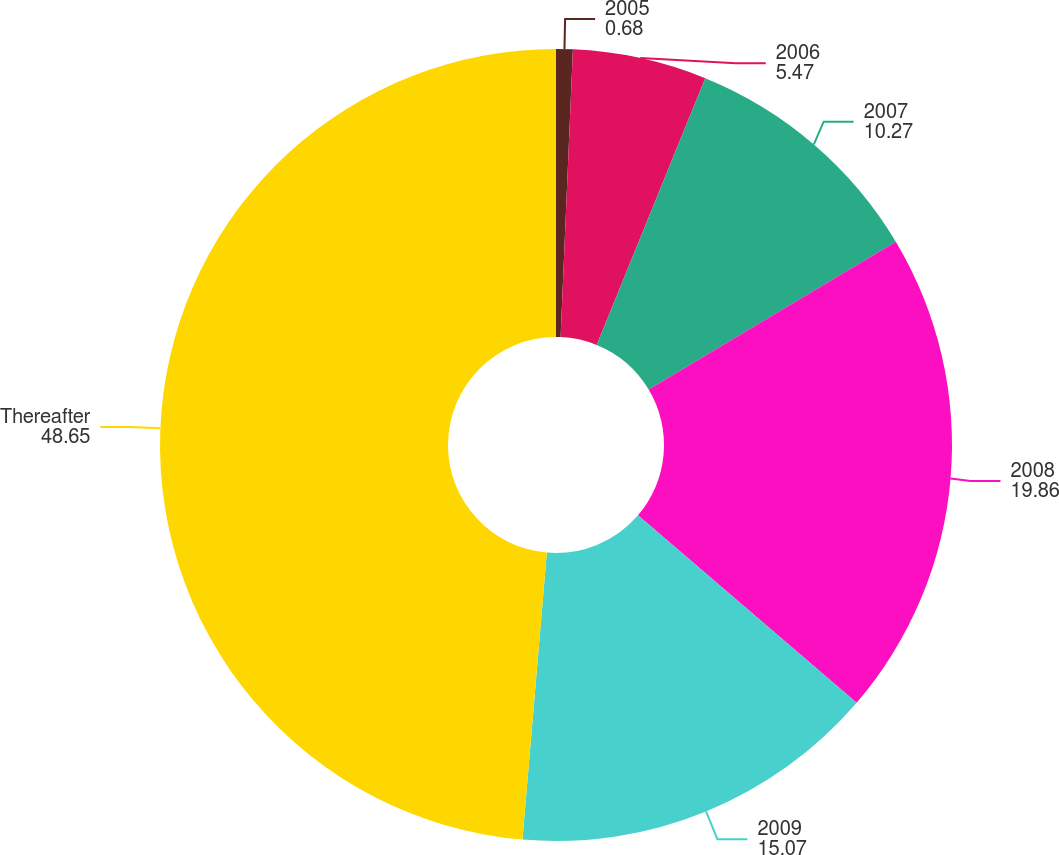<chart> <loc_0><loc_0><loc_500><loc_500><pie_chart><fcel>2005<fcel>2006<fcel>2007<fcel>2008<fcel>2009<fcel>Thereafter<nl><fcel>0.68%<fcel>5.47%<fcel>10.27%<fcel>19.86%<fcel>15.07%<fcel>48.65%<nl></chart> 